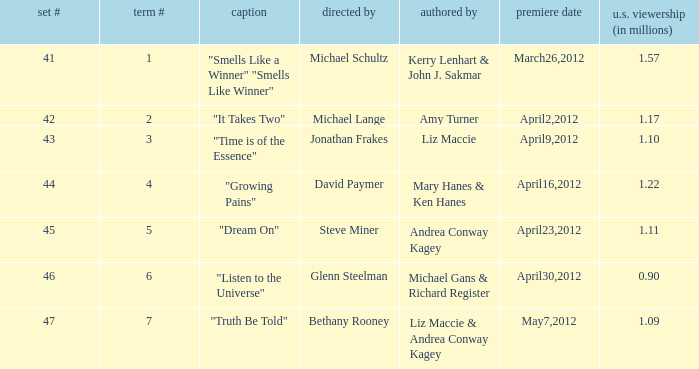What is the title of the episode/s written by Michael Gans & Richard Register? "Listen to the Universe". 